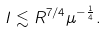<formula> <loc_0><loc_0><loc_500><loc_500>I \lesssim R ^ { 7 / 4 } \mu ^ { - \frac { 1 } { 4 } } .</formula> 